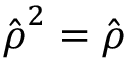Convert formula to latex. <formula><loc_0><loc_0><loc_500><loc_500>\hat { \rho } ^ { 2 } = \hat { \rho }</formula> 